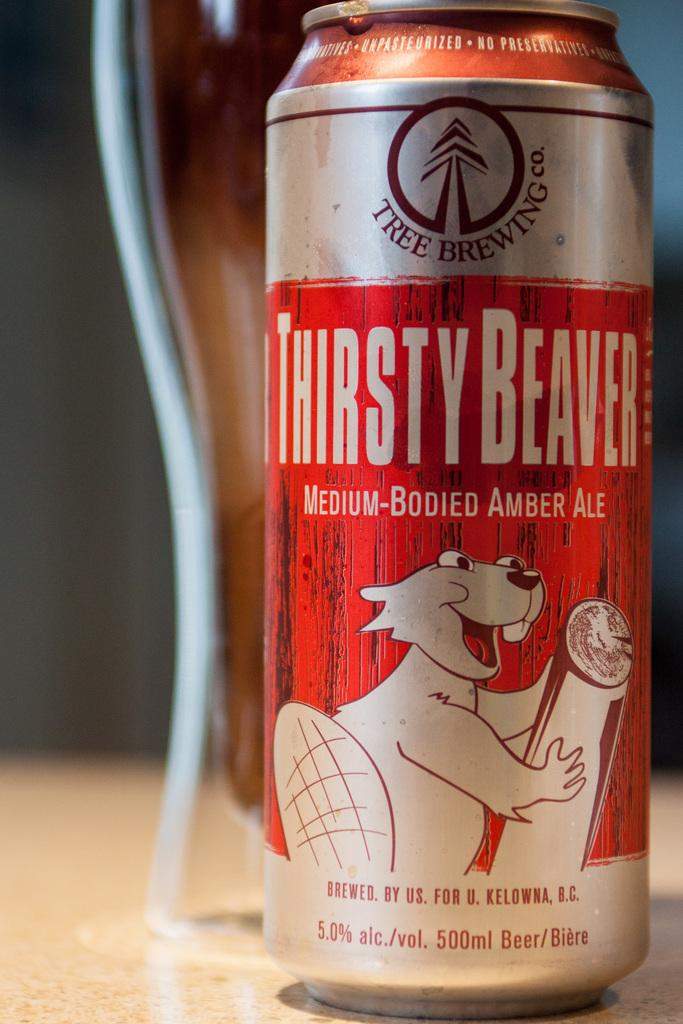<image>
Offer a succinct explanation of the picture presented. A can of thirsty Beaver medium bodied amber ale. 